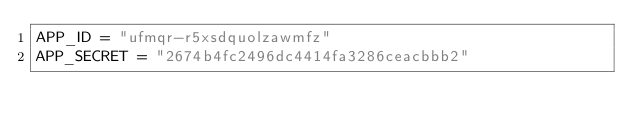Convert code to text. <code><loc_0><loc_0><loc_500><loc_500><_Python_>APP_ID = "ufmqr-r5xsdquolzawmfz"
APP_SECRET = "2674b4fc2496dc4414fa3286ceacbbb2"
</code> 